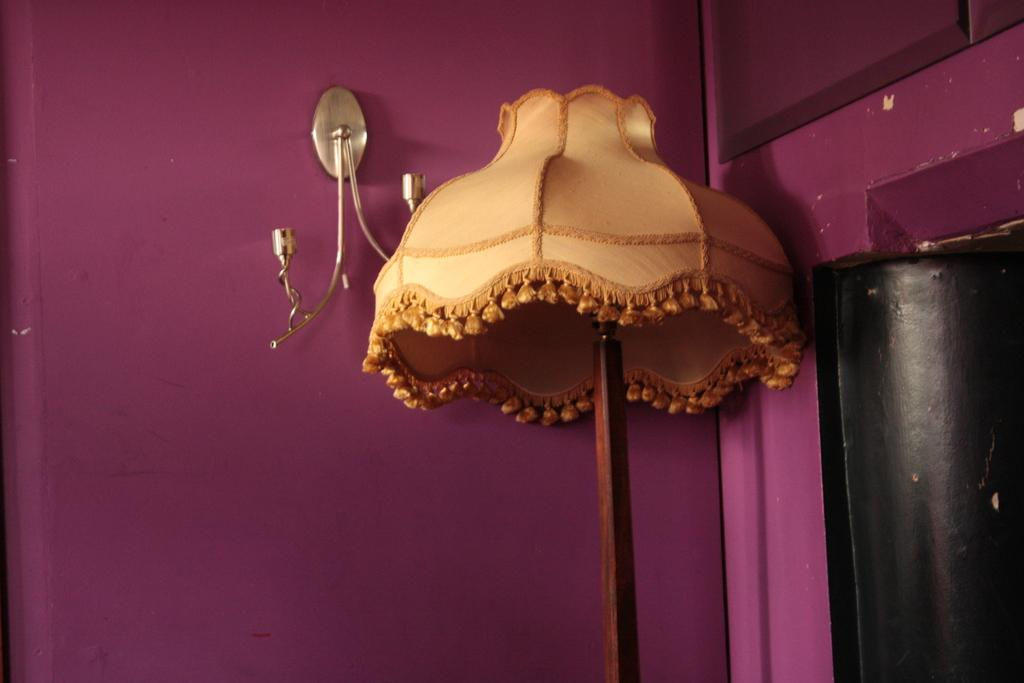What type of lighting fixture is present in the image? There is a table lamp in the image. Can you describe the object on the wall in the image? Unfortunately, the provided facts do not give any information about the object on the wall. However, we can still discuss the table lamp. What is the price of the passenger seat in the image? There is no passenger seat present in the image, and therefore no price can be determined. 